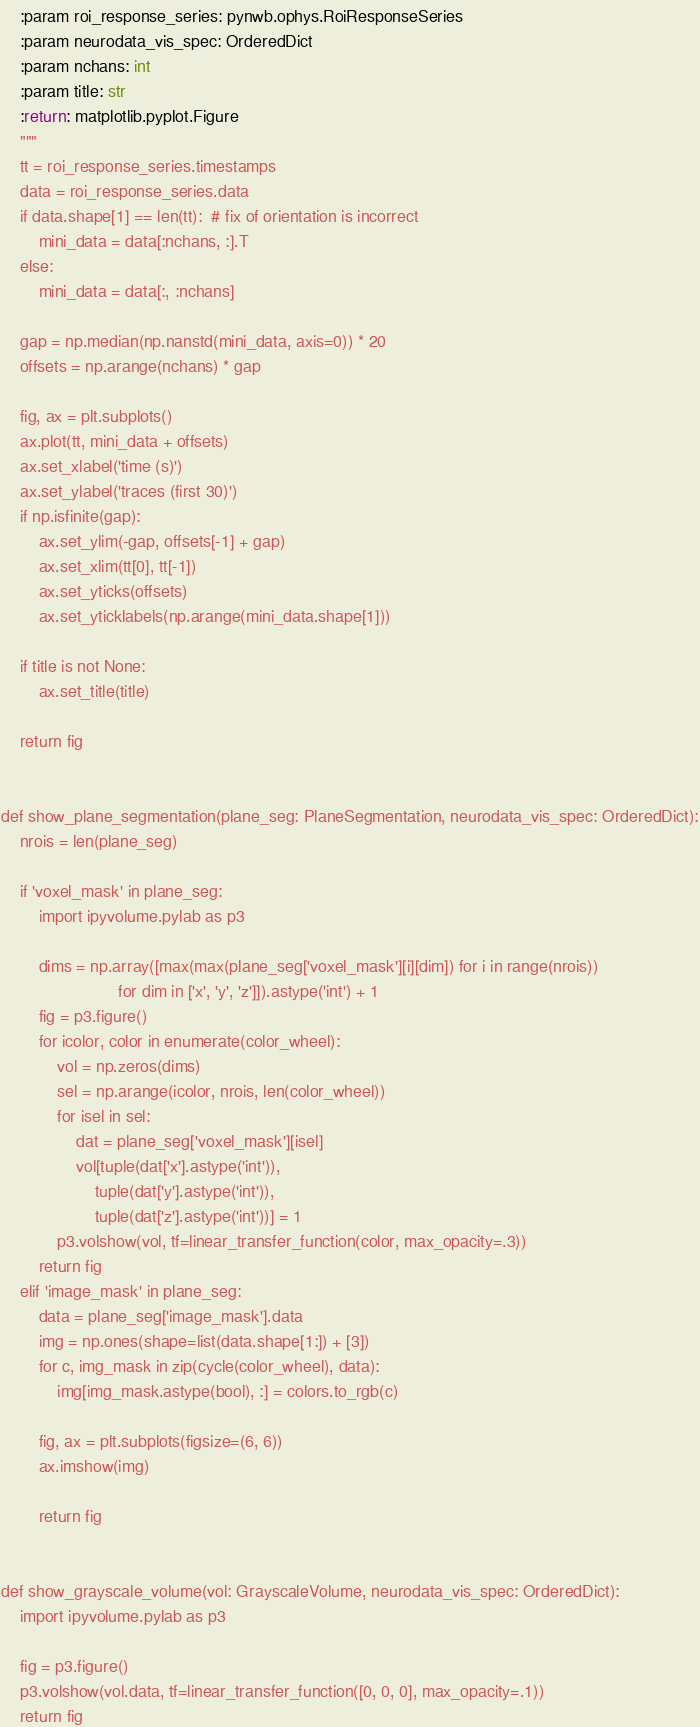Convert code to text. <code><loc_0><loc_0><loc_500><loc_500><_Python_>    :param roi_response_series: pynwb.ophys.RoiResponseSeries
    :param neurodata_vis_spec: OrderedDict
    :param nchans: int
    :param title: str
    :return: matplotlib.pyplot.Figure
    """
    tt = roi_response_series.timestamps
    data = roi_response_series.data
    if data.shape[1] == len(tt):  # fix of orientation is incorrect
        mini_data = data[:nchans, :].T
    else:
        mini_data = data[:, :nchans]

    gap = np.median(np.nanstd(mini_data, axis=0)) * 20
    offsets = np.arange(nchans) * gap

    fig, ax = plt.subplots()
    ax.plot(tt, mini_data + offsets)
    ax.set_xlabel('time (s)')
    ax.set_ylabel('traces (first 30)')
    if np.isfinite(gap):
        ax.set_ylim(-gap, offsets[-1] + gap)
        ax.set_xlim(tt[0], tt[-1])
        ax.set_yticks(offsets)
        ax.set_yticklabels(np.arange(mini_data.shape[1]))

    if title is not None:
        ax.set_title(title)

    return fig


def show_plane_segmentation(plane_seg: PlaneSegmentation, neurodata_vis_spec: OrderedDict):
    nrois = len(plane_seg)

    if 'voxel_mask' in plane_seg:
        import ipyvolume.pylab as p3

        dims = np.array([max(max(plane_seg['voxel_mask'][i][dim]) for i in range(nrois))
                         for dim in ['x', 'y', 'z']]).astype('int') + 1
        fig = p3.figure()
        for icolor, color in enumerate(color_wheel):
            vol = np.zeros(dims)
            sel = np.arange(icolor, nrois, len(color_wheel))
            for isel in sel:
                dat = plane_seg['voxel_mask'][isel]
                vol[tuple(dat['x'].astype('int')),
                    tuple(dat['y'].astype('int')),
                    tuple(dat['z'].astype('int'))] = 1
            p3.volshow(vol, tf=linear_transfer_function(color, max_opacity=.3))
        return fig
    elif 'image_mask' in plane_seg:
        data = plane_seg['image_mask'].data
        img = np.ones(shape=list(data.shape[1:]) + [3])
        for c, img_mask in zip(cycle(color_wheel), data):
            img[img_mask.astype(bool), :] = colors.to_rgb(c)

        fig, ax = plt.subplots(figsize=(6, 6))
        ax.imshow(img)

        return fig


def show_grayscale_volume(vol: GrayscaleVolume, neurodata_vis_spec: OrderedDict):
    import ipyvolume.pylab as p3

    fig = p3.figure()
    p3.volshow(vol.data, tf=linear_transfer_function([0, 0, 0], max_opacity=.1))
    return fig
</code> 